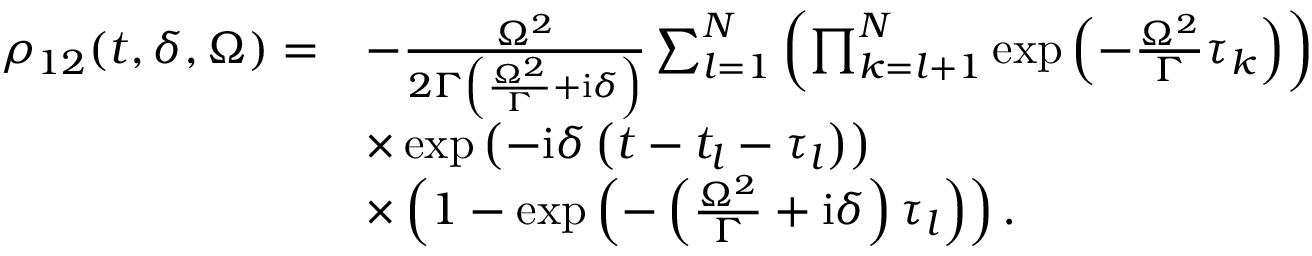<formula> <loc_0><loc_0><loc_500><loc_500>\begin{array} { r l } { \rho _ { 1 2 } ( t , \delta , \Omega ) = } & { - \frac { \Omega ^ { 2 } } { 2 \Gamma \left ( \frac { \Omega ^ { 2 } } { \Gamma } + i \delta \right ) } \sum _ { l = 1 } ^ { N } \left ( \prod _ { k = l + 1 } ^ { N } \exp \left ( - \frac { \Omega ^ { 2 } } { \Gamma } \tau _ { k } \right ) \right ) } \\ & { \times \exp \left ( - i \delta \left ( t - t _ { l } - \tau _ { l } \right ) \right ) } \\ & { \times \left ( 1 - \exp \left ( - \left ( \frac { \Omega ^ { 2 } } { \Gamma } + i \delta \right ) \tau _ { l } \right ) \right ) . } \end{array}</formula> 